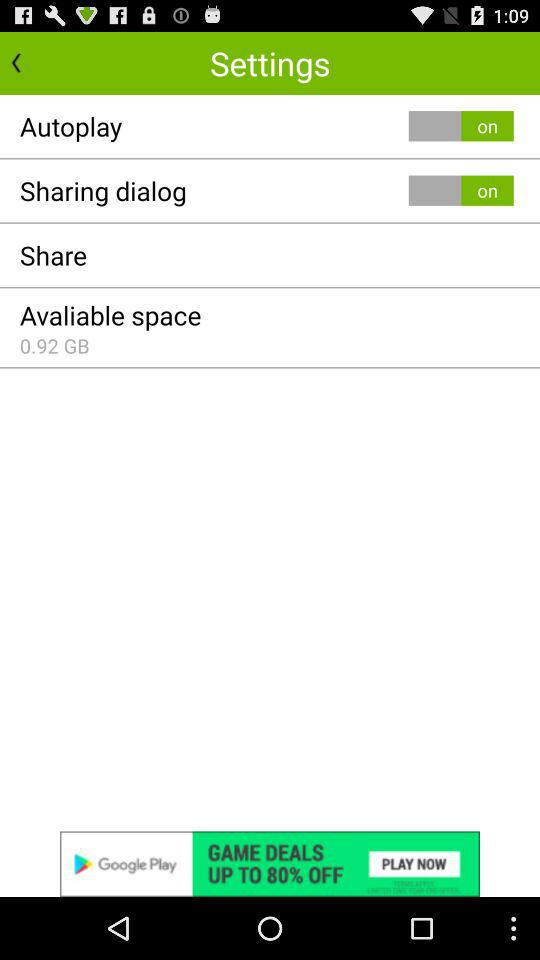How much available space is there?
Answer the question using a single word or phrase. 0.92 GB 